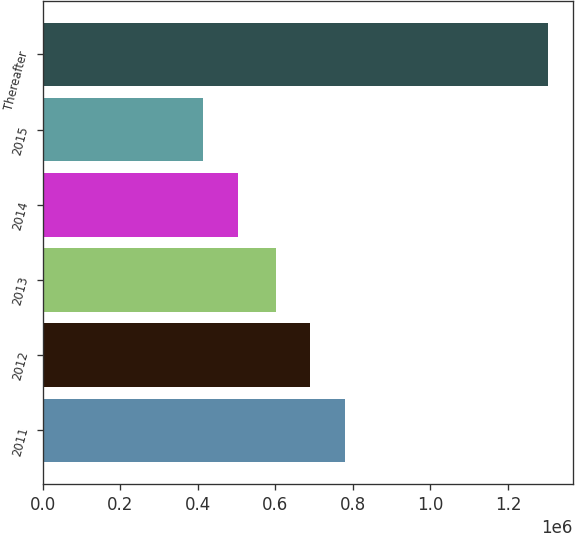<chart> <loc_0><loc_0><loc_500><loc_500><bar_chart><fcel>2011<fcel>2012<fcel>2013<fcel>2014<fcel>2015<fcel>Thereafter<nl><fcel>779443<fcel>690619<fcel>601796<fcel>502703<fcel>413880<fcel>1.30211e+06<nl></chart> 